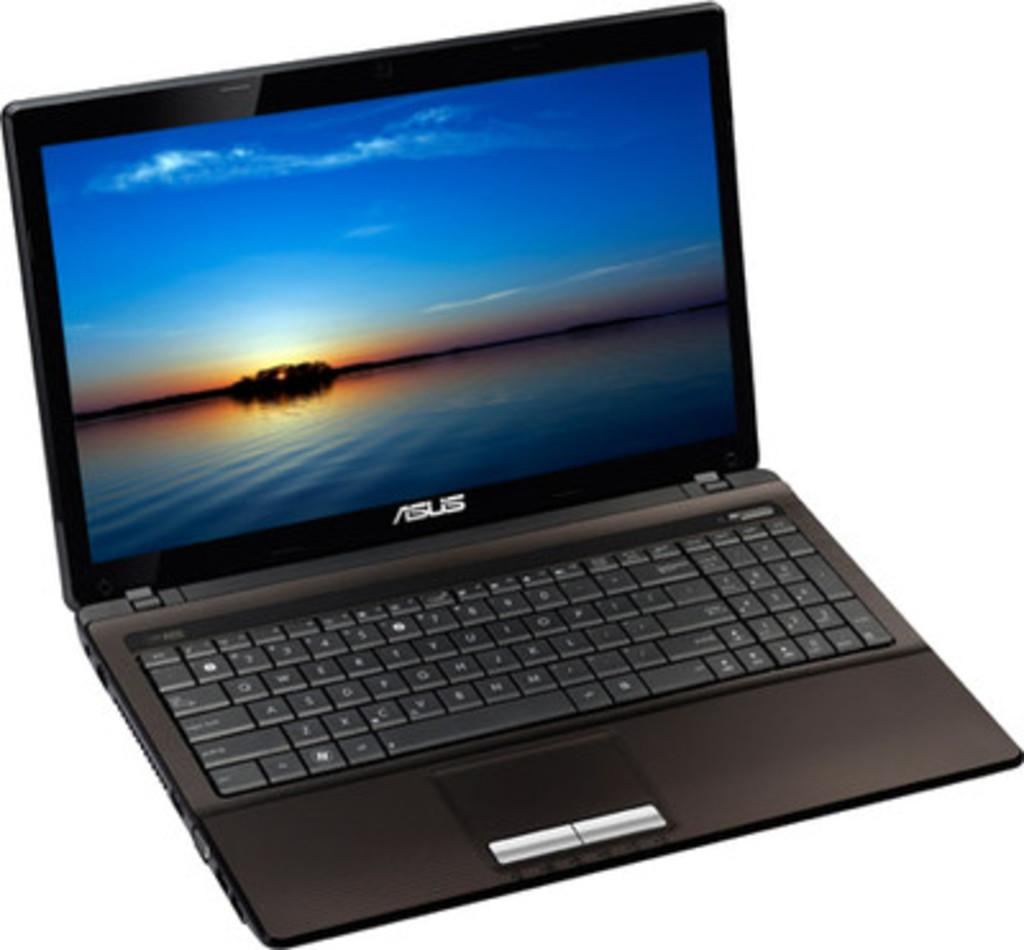What electronic device is visible in the image? There is a laptop in the image. What is the color of the laptop? The laptop is black in color. What is displayed on the laptop screen? The laptop screen displays water and a sky. What is the color of the background in the image? The background of the image is white in color. What verse is being recited by the person in the image? There is no person visible in the image, and therefore no verse being recited. What type of cable is connected to the laptop in the image? There is no cable connected to the laptop in the image. 